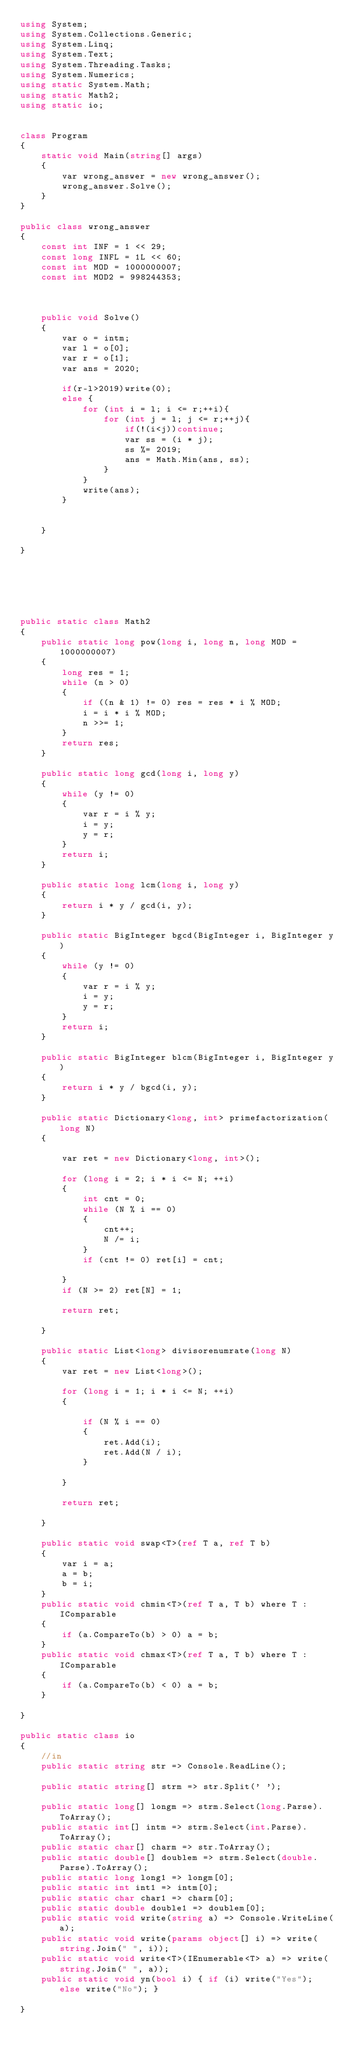<code> <loc_0><loc_0><loc_500><loc_500><_C#_>using System;
using System.Collections.Generic;
using System.Linq;
using System.Text;
using System.Threading.Tasks;
using System.Numerics;
using static System.Math;
using static Math2;
using static io;


class Program
{
    static void Main(string[] args)
    {
        var wrong_answer = new wrong_answer();
        wrong_answer.Solve();
    }
}

public class wrong_answer
{
    const int INF = 1 << 29;
    const long INFL = 1L << 60;
    const int MOD = 1000000007;
    const int MOD2 = 998244353;



    public void Solve()
    {
        var o = intm;
        var l = o[0];
        var r = o[1];
        var ans = 2020;

        if(r-l>2019)write(0);
        else {
            for (int i = l; i <= r;++i){
                for (int j = l; j <= r;++j){
                    if(!(i<j))continue;
                    var ss = (i * j);
                    ss %= 2019;
                    ans = Math.Min(ans, ss);
                }
            }
            write(ans);
        }


    }

}






public static class Math2
{
    public static long pow(long i, long n, long MOD = 1000000007)
    {
        long res = 1;
        while (n > 0)
        {
            if ((n & 1) != 0) res = res * i % MOD;
            i = i * i % MOD;
            n >>= 1;
        }
        return res;
    }

    public static long gcd(long i, long y)
    {
        while (y != 0)
        {
            var r = i % y;
            i = y;
            y = r;
        }
        return i;
    }

    public static long lcm(long i, long y)
    {
        return i * y / gcd(i, y);
    }

    public static BigInteger bgcd(BigInteger i, BigInteger y)
    {
        while (y != 0)
        {
            var r = i % y;
            i = y;
            y = r;
        }
        return i;
    }

    public static BigInteger blcm(BigInteger i, BigInteger y)
    {
        return i * y / bgcd(i, y);
    }

    public static Dictionary<long, int> primefactorization(long N)
    {

        var ret = new Dictionary<long, int>();

        for (long i = 2; i * i <= N; ++i)
        {
            int cnt = 0;
            while (N % i == 0)
            {
                cnt++;
                N /= i;
            }
            if (cnt != 0) ret[i] = cnt;

        }
        if (N >= 2) ret[N] = 1;

        return ret;

    }

    public static List<long> divisorenumrate(long N)
    {
        var ret = new List<long>();

        for (long i = 1; i * i <= N; ++i)
        {

            if (N % i == 0)
            {
                ret.Add(i);
                ret.Add(N / i);
            }

        }

        return ret;

    }

    public static void swap<T>(ref T a, ref T b)
    {
        var i = a;
        a = b;
        b = i;
    }
    public static void chmin<T>(ref T a, T b) where T : IComparable
    {
        if (a.CompareTo(b) > 0) a = b;
    }
    public static void chmax<T>(ref T a, T b) where T : IComparable
    {
        if (a.CompareTo(b) < 0) a = b;
    }

}

public static class io
{
    //in
    public static string str => Console.ReadLine();

    public static string[] strm => str.Split(' ');

    public static long[] longm => strm.Select(long.Parse).ToArray();
    public static int[] intm => strm.Select(int.Parse).ToArray();
    public static char[] charm => str.ToArray();
    public static double[] doublem => strm.Select(double.Parse).ToArray();
    public static long long1 => longm[0];
    public static int int1 => intm[0];
    public static char char1 => charm[0];
    public static double double1 => doublem[0];
    public static void write(string a) => Console.WriteLine(a);
    public static void write(params object[] i) => write(string.Join(" ", i));
    public static void write<T>(IEnumerable<T> a) => write(string.Join(" ", a));
    public static void yn(bool i) { if (i) write("Yes"); else write("No"); }

}
</code> 